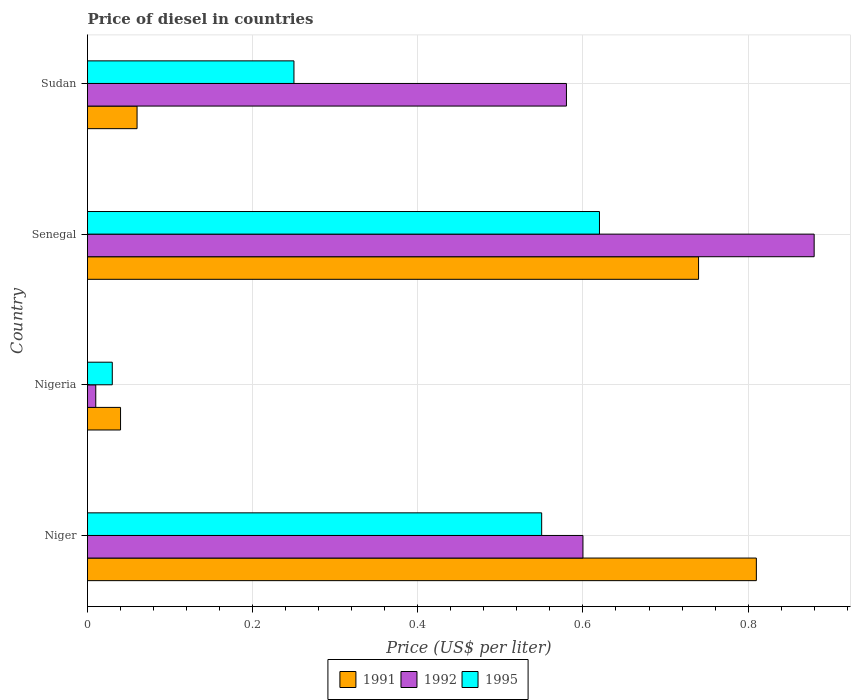Are the number of bars per tick equal to the number of legend labels?
Your answer should be very brief. Yes. What is the label of the 2nd group of bars from the top?
Make the answer very short. Senegal. In how many cases, is the number of bars for a given country not equal to the number of legend labels?
Make the answer very short. 0. What is the price of diesel in 1995 in Niger?
Your response must be concise. 0.55. Across all countries, what is the maximum price of diesel in 1991?
Your answer should be very brief. 0.81. In which country was the price of diesel in 1995 maximum?
Your response must be concise. Senegal. In which country was the price of diesel in 1992 minimum?
Your response must be concise. Nigeria. What is the total price of diesel in 1995 in the graph?
Make the answer very short. 1.45. What is the difference between the price of diesel in 1991 in Senegal and that in Sudan?
Provide a short and direct response. 0.68. What is the difference between the price of diesel in 1992 in Sudan and the price of diesel in 1991 in Nigeria?
Give a very brief answer. 0.54. What is the average price of diesel in 1991 per country?
Keep it short and to the point. 0.41. What is the difference between the price of diesel in 1991 and price of diesel in 1995 in Sudan?
Offer a very short reply. -0.19. In how many countries, is the price of diesel in 1991 greater than 0.48000000000000004 US$?
Offer a very short reply. 2. What is the ratio of the price of diesel in 1995 in Niger to that in Nigeria?
Provide a short and direct response. 18.33. What is the difference between the highest and the second highest price of diesel in 1992?
Provide a short and direct response. 0.28. What is the difference between the highest and the lowest price of diesel in 1991?
Your answer should be compact. 0.77. What does the 3rd bar from the top in Niger represents?
Offer a very short reply. 1991. Is it the case that in every country, the sum of the price of diesel in 1995 and price of diesel in 1992 is greater than the price of diesel in 1991?
Provide a succinct answer. No. How many countries are there in the graph?
Provide a short and direct response. 4. What is the difference between two consecutive major ticks on the X-axis?
Ensure brevity in your answer.  0.2. Are the values on the major ticks of X-axis written in scientific E-notation?
Offer a terse response. No. Does the graph contain grids?
Offer a terse response. Yes. Where does the legend appear in the graph?
Ensure brevity in your answer.  Bottom center. How many legend labels are there?
Your response must be concise. 3. How are the legend labels stacked?
Your response must be concise. Horizontal. What is the title of the graph?
Offer a terse response. Price of diesel in countries. Does "2004" appear as one of the legend labels in the graph?
Provide a short and direct response. No. What is the label or title of the X-axis?
Provide a succinct answer. Price (US$ per liter). What is the label or title of the Y-axis?
Offer a very short reply. Country. What is the Price (US$ per liter) of 1991 in Niger?
Your answer should be very brief. 0.81. What is the Price (US$ per liter) of 1995 in Niger?
Give a very brief answer. 0.55. What is the Price (US$ per liter) of 1991 in Nigeria?
Ensure brevity in your answer.  0.04. What is the Price (US$ per liter) of 1992 in Nigeria?
Provide a short and direct response. 0.01. What is the Price (US$ per liter) in 1995 in Nigeria?
Offer a terse response. 0.03. What is the Price (US$ per liter) in 1991 in Senegal?
Ensure brevity in your answer.  0.74. What is the Price (US$ per liter) in 1992 in Senegal?
Offer a very short reply. 0.88. What is the Price (US$ per liter) in 1995 in Senegal?
Offer a very short reply. 0.62. What is the Price (US$ per liter) in 1992 in Sudan?
Your answer should be very brief. 0.58. Across all countries, what is the maximum Price (US$ per liter) in 1991?
Offer a very short reply. 0.81. Across all countries, what is the maximum Price (US$ per liter) in 1995?
Your response must be concise. 0.62. Across all countries, what is the minimum Price (US$ per liter) in 1991?
Your answer should be very brief. 0.04. Across all countries, what is the minimum Price (US$ per liter) of 1992?
Ensure brevity in your answer.  0.01. What is the total Price (US$ per liter) in 1991 in the graph?
Make the answer very short. 1.65. What is the total Price (US$ per liter) of 1992 in the graph?
Make the answer very short. 2.07. What is the total Price (US$ per liter) of 1995 in the graph?
Your response must be concise. 1.45. What is the difference between the Price (US$ per liter) of 1991 in Niger and that in Nigeria?
Your answer should be very brief. 0.77. What is the difference between the Price (US$ per liter) in 1992 in Niger and that in Nigeria?
Your answer should be very brief. 0.59. What is the difference between the Price (US$ per liter) of 1995 in Niger and that in Nigeria?
Your response must be concise. 0.52. What is the difference between the Price (US$ per liter) of 1991 in Niger and that in Senegal?
Your answer should be very brief. 0.07. What is the difference between the Price (US$ per liter) of 1992 in Niger and that in Senegal?
Provide a short and direct response. -0.28. What is the difference between the Price (US$ per liter) of 1995 in Niger and that in Senegal?
Your answer should be very brief. -0.07. What is the difference between the Price (US$ per liter) of 1991 in Niger and that in Sudan?
Give a very brief answer. 0.75. What is the difference between the Price (US$ per liter) in 1995 in Niger and that in Sudan?
Provide a succinct answer. 0.3. What is the difference between the Price (US$ per liter) in 1992 in Nigeria and that in Senegal?
Ensure brevity in your answer.  -0.87. What is the difference between the Price (US$ per liter) of 1995 in Nigeria and that in Senegal?
Give a very brief answer. -0.59. What is the difference between the Price (US$ per liter) in 1991 in Nigeria and that in Sudan?
Offer a terse response. -0.02. What is the difference between the Price (US$ per liter) in 1992 in Nigeria and that in Sudan?
Keep it short and to the point. -0.57. What is the difference between the Price (US$ per liter) in 1995 in Nigeria and that in Sudan?
Keep it short and to the point. -0.22. What is the difference between the Price (US$ per liter) of 1991 in Senegal and that in Sudan?
Make the answer very short. 0.68. What is the difference between the Price (US$ per liter) of 1995 in Senegal and that in Sudan?
Keep it short and to the point. 0.37. What is the difference between the Price (US$ per liter) in 1991 in Niger and the Price (US$ per liter) in 1992 in Nigeria?
Your answer should be compact. 0.8. What is the difference between the Price (US$ per liter) in 1991 in Niger and the Price (US$ per liter) in 1995 in Nigeria?
Your answer should be very brief. 0.78. What is the difference between the Price (US$ per liter) of 1992 in Niger and the Price (US$ per liter) of 1995 in Nigeria?
Your answer should be compact. 0.57. What is the difference between the Price (US$ per liter) in 1991 in Niger and the Price (US$ per liter) in 1992 in Senegal?
Make the answer very short. -0.07. What is the difference between the Price (US$ per liter) of 1991 in Niger and the Price (US$ per liter) of 1995 in Senegal?
Make the answer very short. 0.19. What is the difference between the Price (US$ per liter) in 1992 in Niger and the Price (US$ per liter) in 1995 in Senegal?
Ensure brevity in your answer.  -0.02. What is the difference between the Price (US$ per liter) of 1991 in Niger and the Price (US$ per liter) of 1992 in Sudan?
Provide a succinct answer. 0.23. What is the difference between the Price (US$ per liter) in 1991 in Niger and the Price (US$ per liter) in 1995 in Sudan?
Provide a short and direct response. 0.56. What is the difference between the Price (US$ per liter) in 1991 in Nigeria and the Price (US$ per liter) in 1992 in Senegal?
Make the answer very short. -0.84. What is the difference between the Price (US$ per liter) of 1991 in Nigeria and the Price (US$ per liter) of 1995 in Senegal?
Ensure brevity in your answer.  -0.58. What is the difference between the Price (US$ per liter) in 1992 in Nigeria and the Price (US$ per liter) in 1995 in Senegal?
Provide a short and direct response. -0.61. What is the difference between the Price (US$ per liter) in 1991 in Nigeria and the Price (US$ per liter) in 1992 in Sudan?
Make the answer very short. -0.54. What is the difference between the Price (US$ per liter) in 1991 in Nigeria and the Price (US$ per liter) in 1995 in Sudan?
Ensure brevity in your answer.  -0.21. What is the difference between the Price (US$ per liter) in 1992 in Nigeria and the Price (US$ per liter) in 1995 in Sudan?
Provide a succinct answer. -0.24. What is the difference between the Price (US$ per liter) of 1991 in Senegal and the Price (US$ per liter) of 1992 in Sudan?
Provide a short and direct response. 0.16. What is the difference between the Price (US$ per liter) of 1991 in Senegal and the Price (US$ per liter) of 1995 in Sudan?
Ensure brevity in your answer.  0.49. What is the difference between the Price (US$ per liter) of 1992 in Senegal and the Price (US$ per liter) of 1995 in Sudan?
Give a very brief answer. 0.63. What is the average Price (US$ per liter) in 1991 per country?
Offer a terse response. 0.41. What is the average Price (US$ per liter) in 1992 per country?
Give a very brief answer. 0.52. What is the average Price (US$ per liter) of 1995 per country?
Give a very brief answer. 0.36. What is the difference between the Price (US$ per liter) in 1991 and Price (US$ per liter) in 1992 in Niger?
Your answer should be very brief. 0.21. What is the difference between the Price (US$ per liter) of 1991 and Price (US$ per liter) of 1995 in Niger?
Offer a very short reply. 0.26. What is the difference between the Price (US$ per liter) of 1992 and Price (US$ per liter) of 1995 in Niger?
Ensure brevity in your answer.  0.05. What is the difference between the Price (US$ per liter) in 1991 and Price (US$ per liter) in 1995 in Nigeria?
Provide a succinct answer. 0.01. What is the difference between the Price (US$ per liter) in 1992 and Price (US$ per liter) in 1995 in Nigeria?
Offer a very short reply. -0.02. What is the difference between the Price (US$ per liter) of 1991 and Price (US$ per liter) of 1992 in Senegal?
Provide a short and direct response. -0.14. What is the difference between the Price (US$ per liter) in 1991 and Price (US$ per liter) in 1995 in Senegal?
Keep it short and to the point. 0.12. What is the difference between the Price (US$ per liter) in 1992 and Price (US$ per liter) in 1995 in Senegal?
Keep it short and to the point. 0.26. What is the difference between the Price (US$ per liter) of 1991 and Price (US$ per liter) of 1992 in Sudan?
Give a very brief answer. -0.52. What is the difference between the Price (US$ per liter) in 1991 and Price (US$ per liter) in 1995 in Sudan?
Your answer should be very brief. -0.19. What is the difference between the Price (US$ per liter) in 1992 and Price (US$ per liter) in 1995 in Sudan?
Your response must be concise. 0.33. What is the ratio of the Price (US$ per liter) of 1991 in Niger to that in Nigeria?
Offer a terse response. 20.25. What is the ratio of the Price (US$ per liter) of 1992 in Niger to that in Nigeria?
Offer a very short reply. 60. What is the ratio of the Price (US$ per liter) of 1995 in Niger to that in Nigeria?
Your answer should be compact. 18.33. What is the ratio of the Price (US$ per liter) of 1991 in Niger to that in Senegal?
Offer a very short reply. 1.09. What is the ratio of the Price (US$ per liter) of 1992 in Niger to that in Senegal?
Give a very brief answer. 0.68. What is the ratio of the Price (US$ per liter) in 1995 in Niger to that in Senegal?
Provide a short and direct response. 0.89. What is the ratio of the Price (US$ per liter) in 1991 in Niger to that in Sudan?
Make the answer very short. 13.5. What is the ratio of the Price (US$ per liter) of 1992 in Niger to that in Sudan?
Give a very brief answer. 1.03. What is the ratio of the Price (US$ per liter) in 1991 in Nigeria to that in Senegal?
Provide a short and direct response. 0.05. What is the ratio of the Price (US$ per liter) in 1992 in Nigeria to that in Senegal?
Provide a short and direct response. 0.01. What is the ratio of the Price (US$ per liter) of 1995 in Nigeria to that in Senegal?
Ensure brevity in your answer.  0.05. What is the ratio of the Price (US$ per liter) of 1991 in Nigeria to that in Sudan?
Provide a short and direct response. 0.67. What is the ratio of the Price (US$ per liter) of 1992 in Nigeria to that in Sudan?
Provide a short and direct response. 0.02. What is the ratio of the Price (US$ per liter) in 1995 in Nigeria to that in Sudan?
Your answer should be very brief. 0.12. What is the ratio of the Price (US$ per liter) in 1991 in Senegal to that in Sudan?
Your answer should be compact. 12.33. What is the ratio of the Price (US$ per liter) of 1992 in Senegal to that in Sudan?
Give a very brief answer. 1.52. What is the ratio of the Price (US$ per liter) of 1995 in Senegal to that in Sudan?
Provide a short and direct response. 2.48. What is the difference between the highest and the second highest Price (US$ per liter) in 1991?
Make the answer very short. 0.07. What is the difference between the highest and the second highest Price (US$ per liter) of 1992?
Your answer should be compact. 0.28. What is the difference between the highest and the second highest Price (US$ per liter) of 1995?
Offer a terse response. 0.07. What is the difference between the highest and the lowest Price (US$ per liter) in 1991?
Keep it short and to the point. 0.77. What is the difference between the highest and the lowest Price (US$ per liter) in 1992?
Your answer should be very brief. 0.87. What is the difference between the highest and the lowest Price (US$ per liter) in 1995?
Provide a succinct answer. 0.59. 